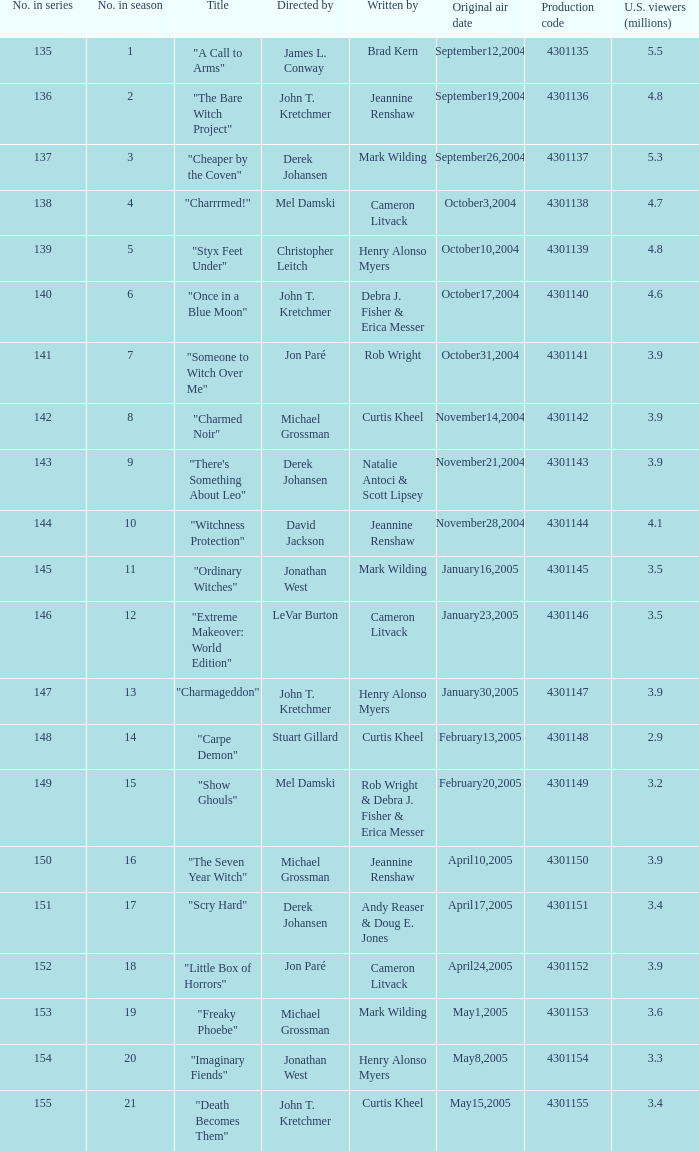Who were the directors of the episode called "someone to witch over me"? Jon Paré. Could you parse the entire table? {'header': ['No. in series', 'No. in season', 'Title', 'Directed by', 'Written by', 'Original air date', 'Production code', 'U.S. viewers (millions)'], 'rows': [['135', '1', '"A Call to Arms"', 'James L. Conway', 'Brad Kern', 'September12,2004', '4301135', '5.5'], ['136', '2', '"The Bare Witch Project"', 'John T. Kretchmer', 'Jeannine Renshaw', 'September19,2004', '4301136', '4.8'], ['137', '3', '"Cheaper by the Coven"', 'Derek Johansen', 'Mark Wilding', 'September26,2004', '4301137', '5.3'], ['138', '4', '"Charrrmed!"', 'Mel Damski', 'Cameron Litvack', 'October3,2004', '4301138', '4.7'], ['139', '5', '"Styx Feet Under"', 'Christopher Leitch', 'Henry Alonso Myers', 'October10,2004', '4301139', '4.8'], ['140', '6', '"Once in a Blue Moon"', 'John T. Kretchmer', 'Debra J. Fisher & Erica Messer', 'October17,2004', '4301140', '4.6'], ['141', '7', '"Someone to Witch Over Me"', 'Jon Paré', 'Rob Wright', 'October31,2004', '4301141', '3.9'], ['142', '8', '"Charmed Noir"', 'Michael Grossman', 'Curtis Kheel', 'November14,2004', '4301142', '3.9'], ['143', '9', '"There\'s Something About Leo"', 'Derek Johansen', 'Natalie Antoci & Scott Lipsey', 'November21,2004', '4301143', '3.9'], ['144', '10', '"Witchness Protection"', 'David Jackson', 'Jeannine Renshaw', 'November28,2004', '4301144', '4.1'], ['145', '11', '"Ordinary Witches"', 'Jonathan West', 'Mark Wilding', 'January16,2005', '4301145', '3.5'], ['146', '12', '"Extreme Makeover: World Edition"', 'LeVar Burton', 'Cameron Litvack', 'January23,2005', '4301146', '3.5'], ['147', '13', '"Charmageddon"', 'John T. Kretchmer', 'Henry Alonso Myers', 'January30,2005', '4301147', '3.9'], ['148', '14', '"Carpe Demon"', 'Stuart Gillard', 'Curtis Kheel', 'February13,2005', '4301148', '2.9'], ['149', '15', '"Show Ghouls"', 'Mel Damski', 'Rob Wright & Debra J. Fisher & Erica Messer', 'February20,2005', '4301149', '3.2'], ['150', '16', '"The Seven Year Witch"', 'Michael Grossman', 'Jeannine Renshaw', 'April10,2005', '4301150', '3.9'], ['151', '17', '"Scry Hard"', 'Derek Johansen', 'Andy Reaser & Doug E. Jones', 'April17,2005', '4301151', '3.4'], ['152', '18', '"Little Box of Horrors"', 'Jon Paré', 'Cameron Litvack', 'April24,2005', '4301152', '3.9'], ['153', '19', '"Freaky Phoebe"', 'Michael Grossman', 'Mark Wilding', 'May1,2005', '4301153', '3.6'], ['154', '20', '"Imaginary Fiends"', 'Jonathan West', 'Henry Alonso Myers', 'May8,2005', '4301154', '3.3'], ['155', '21', '"Death Becomes Them"', 'John T. Kretchmer', 'Curtis Kheel', 'May15,2005', '4301155', '3.4']]} 